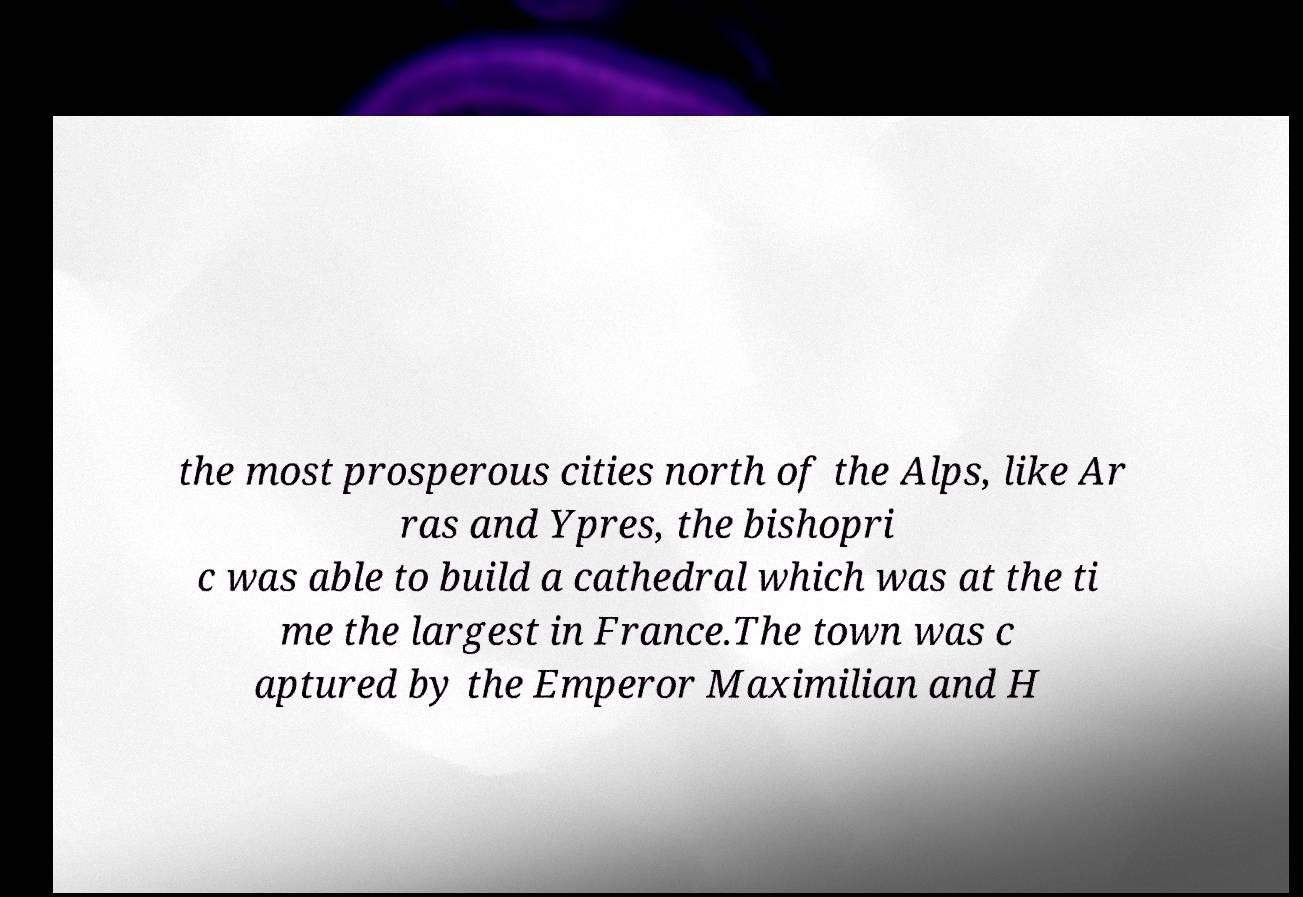Please read and relay the text visible in this image. What does it say? the most prosperous cities north of the Alps, like Ar ras and Ypres, the bishopri c was able to build a cathedral which was at the ti me the largest in France.The town was c aptured by the Emperor Maximilian and H 